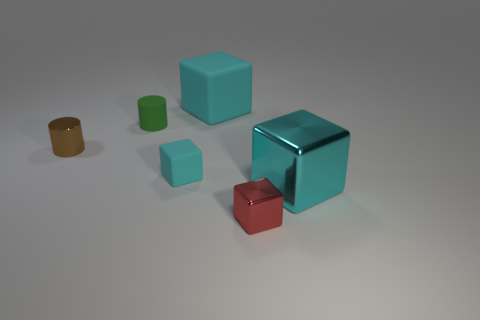Are the large block behind the brown thing and the big cube that is in front of the tiny cyan object made of the same material?
Keep it short and to the point. No. What is the tiny cyan object made of?
Your answer should be compact. Rubber. How many green objects are the same material as the small red thing?
Provide a succinct answer. 0. What number of metallic things are either big cubes or small blocks?
Offer a terse response. 2. There is a cyan thing that is behind the brown cylinder; does it have the same shape as the cyan thing that is on the right side of the red shiny block?
Offer a terse response. Yes. There is a thing that is right of the small green rubber cylinder and behind the tiny brown metallic cylinder; what is its color?
Keep it short and to the point. Cyan. There is a cyan matte block that is in front of the brown shiny cylinder; is it the same size as the metal cube that is on the right side of the red metal object?
Offer a very short reply. No. How many other shiny objects are the same color as the large metallic object?
Your answer should be very brief. 0. What number of large objects are rubber cylinders or red shiny blocks?
Offer a terse response. 0. Do the big cyan block left of the red block and the small brown object have the same material?
Your response must be concise. No. 